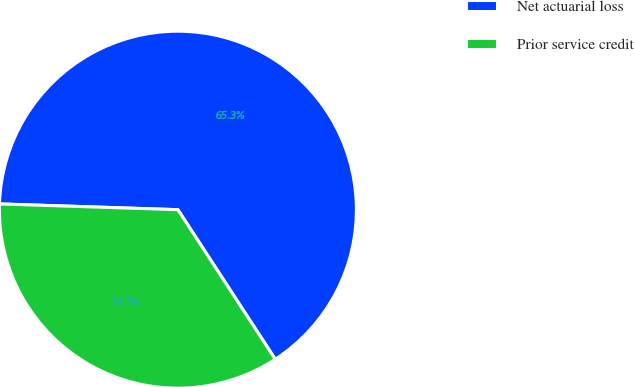Convert chart. <chart><loc_0><loc_0><loc_500><loc_500><pie_chart><fcel>Net actuarial loss<fcel>Prior service credit<nl><fcel>65.3%<fcel>34.7%<nl></chart> 